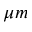Convert formula to latex. <formula><loc_0><loc_0><loc_500><loc_500>\mu m</formula> 